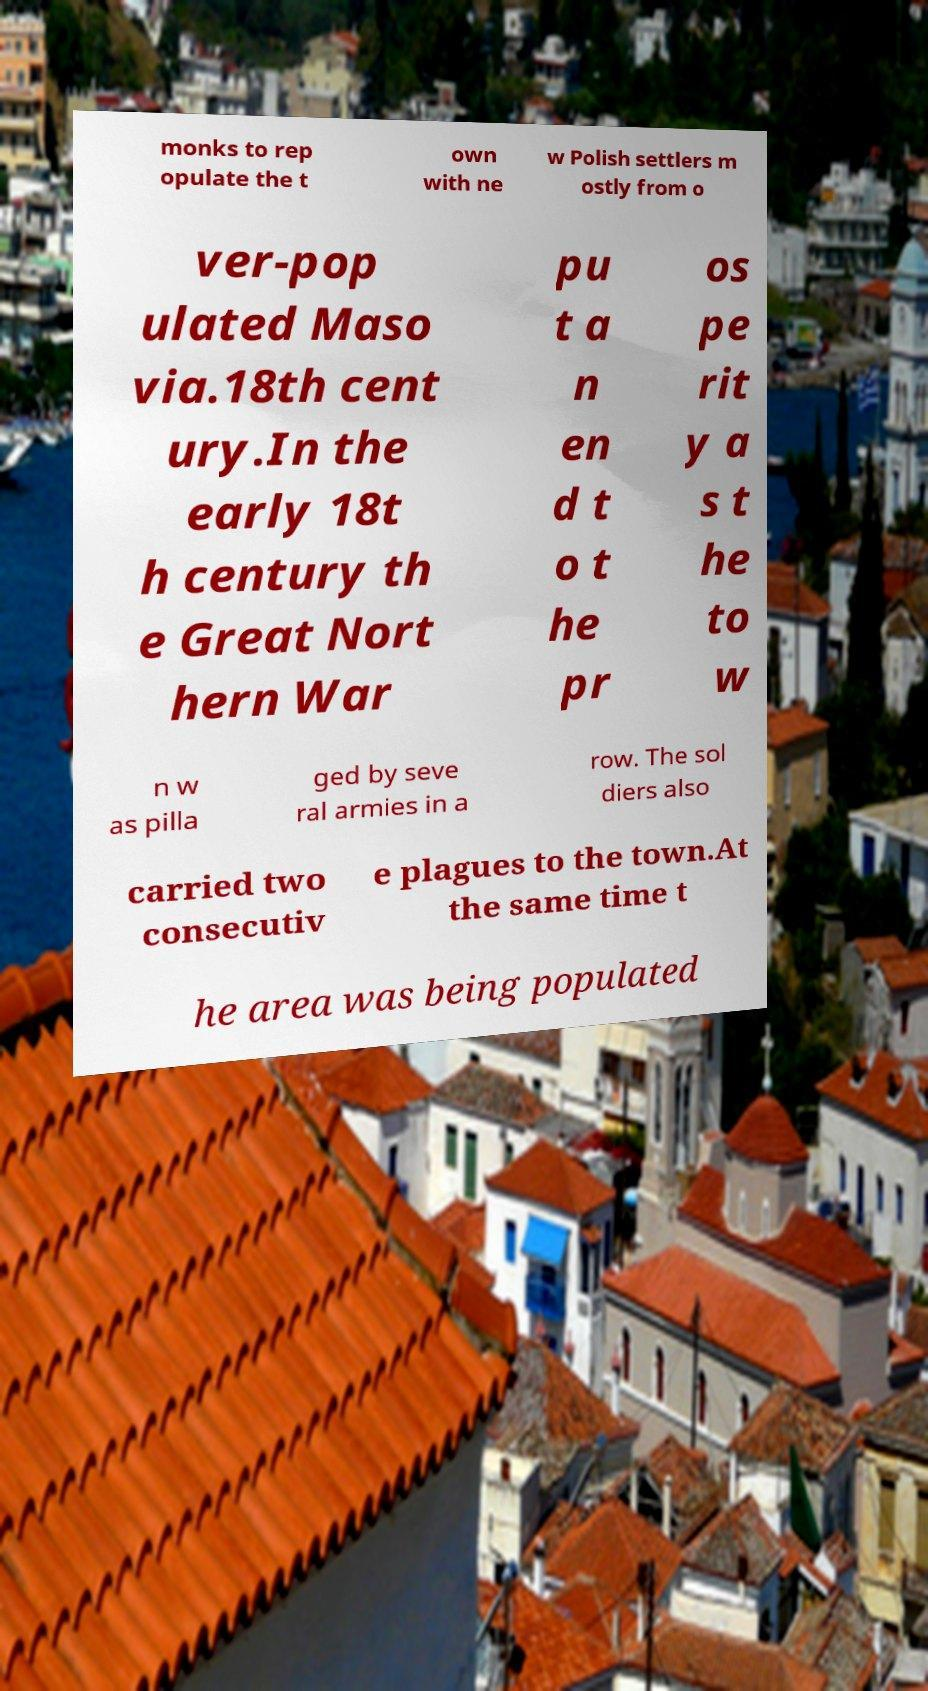Can you accurately transcribe the text from the provided image for me? monks to rep opulate the t own with ne w Polish settlers m ostly from o ver-pop ulated Maso via.18th cent ury.In the early 18t h century th e Great Nort hern War pu t a n en d t o t he pr os pe rit y a s t he to w n w as pilla ged by seve ral armies in a row. The sol diers also carried two consecutiv e plagues to the town.At the same time t he area was being populated 